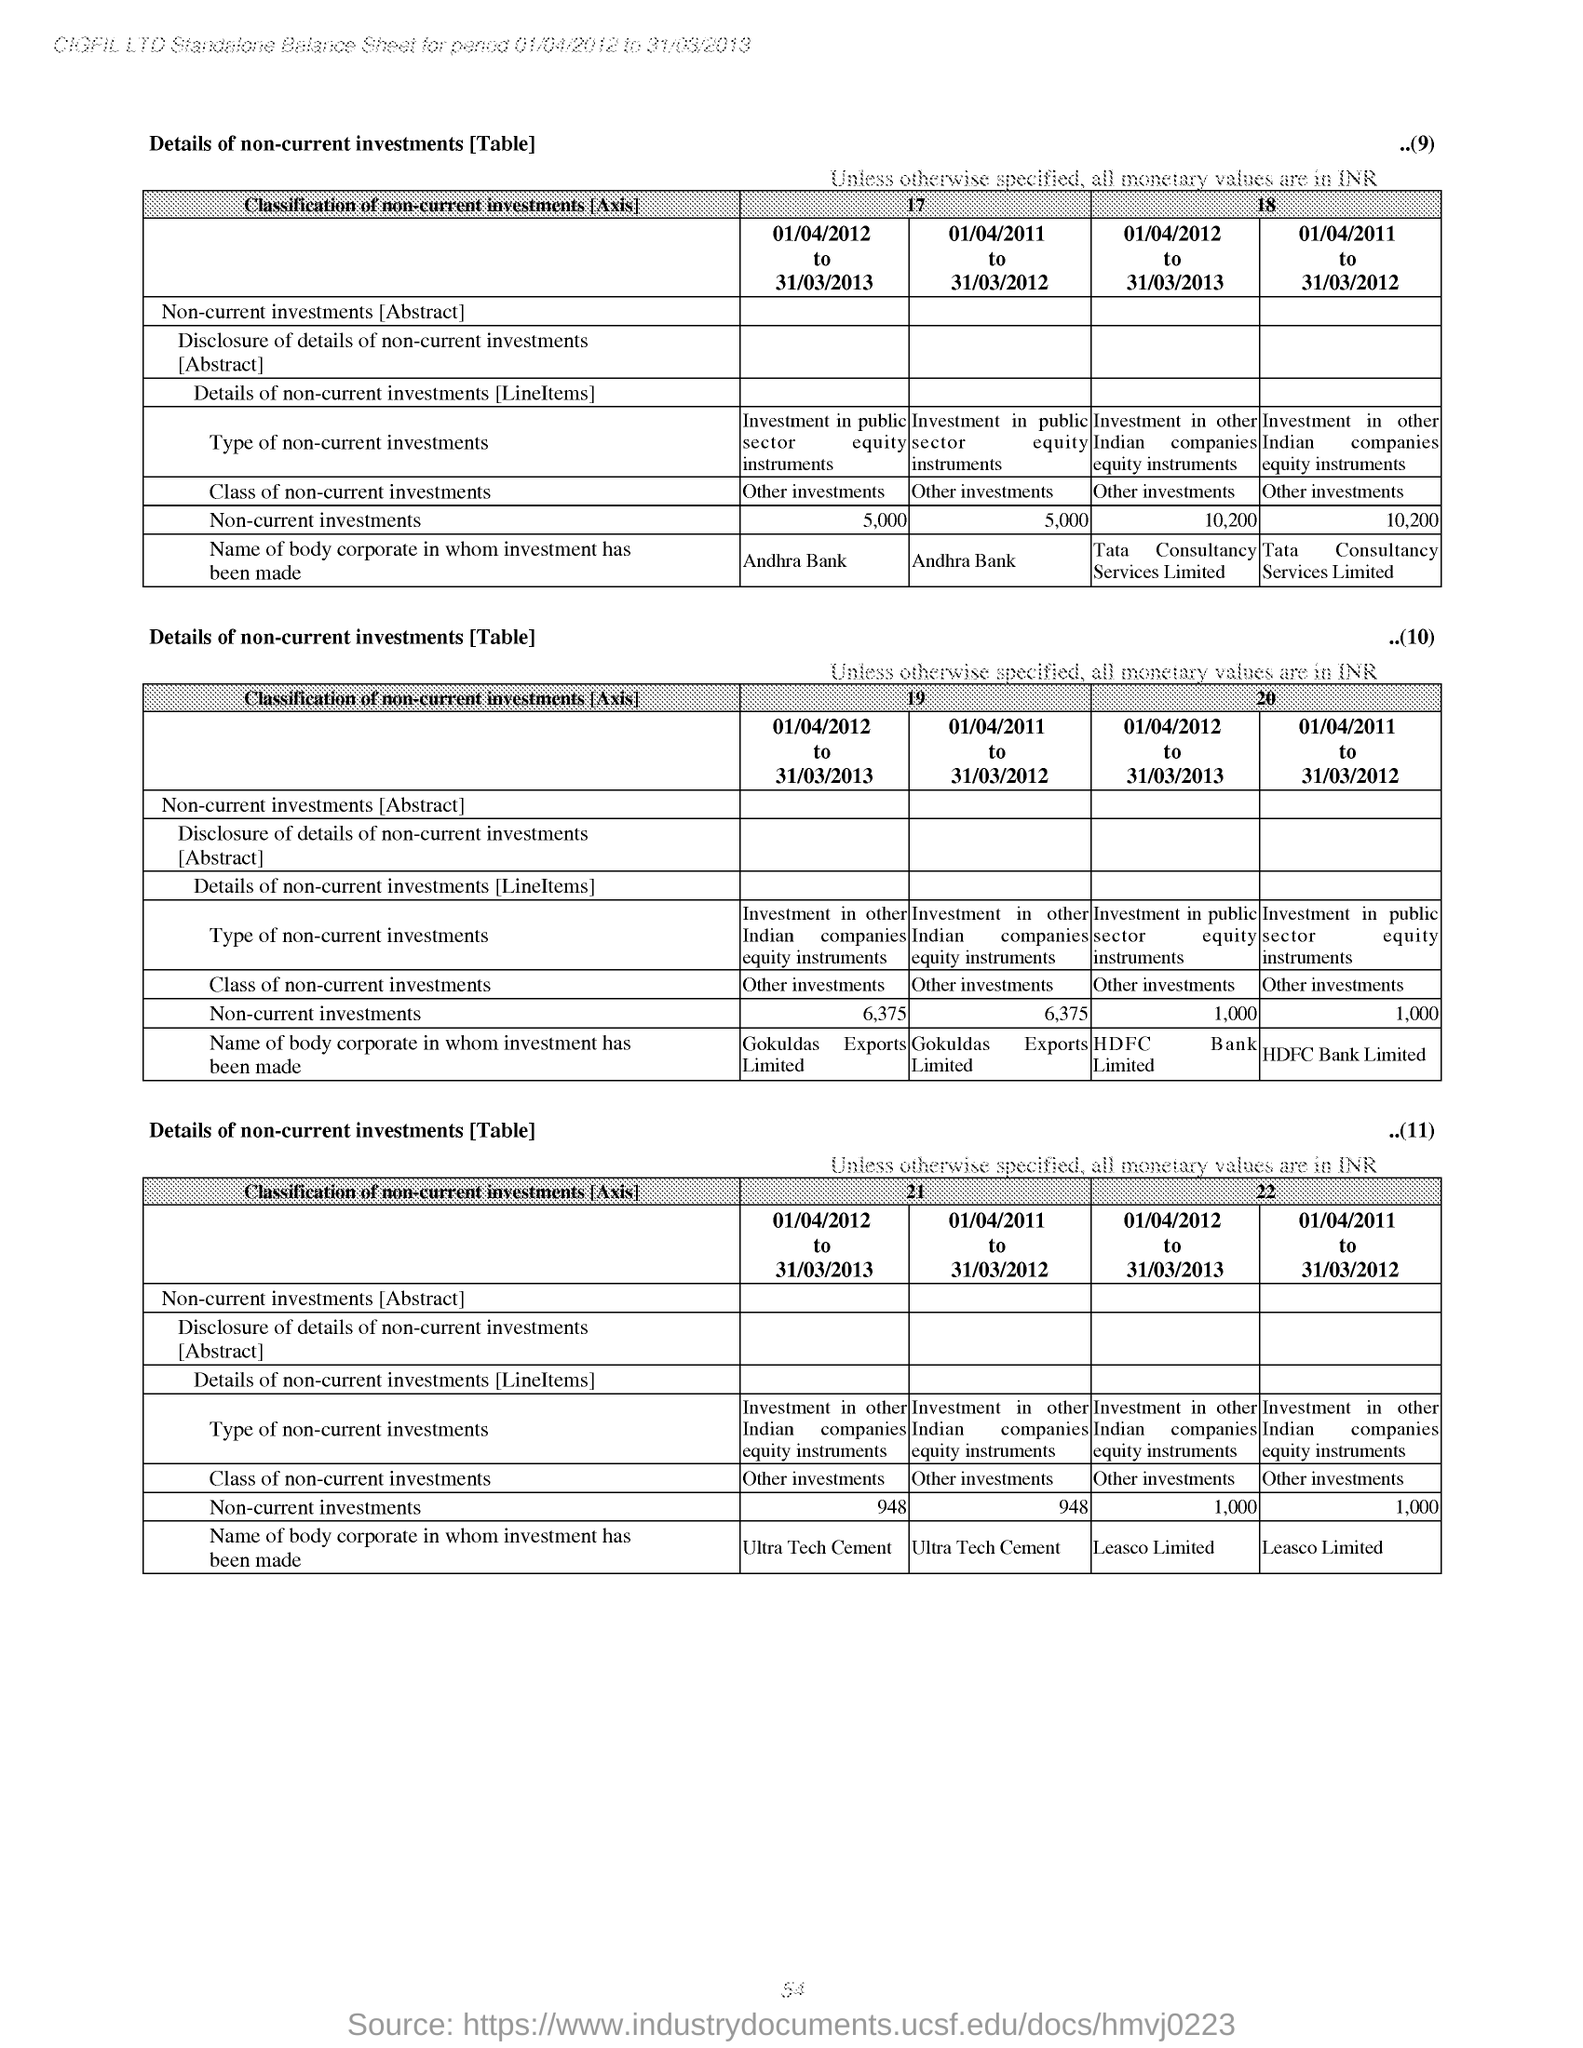What is the Page Number?
Provide a short and direct response. 54. 